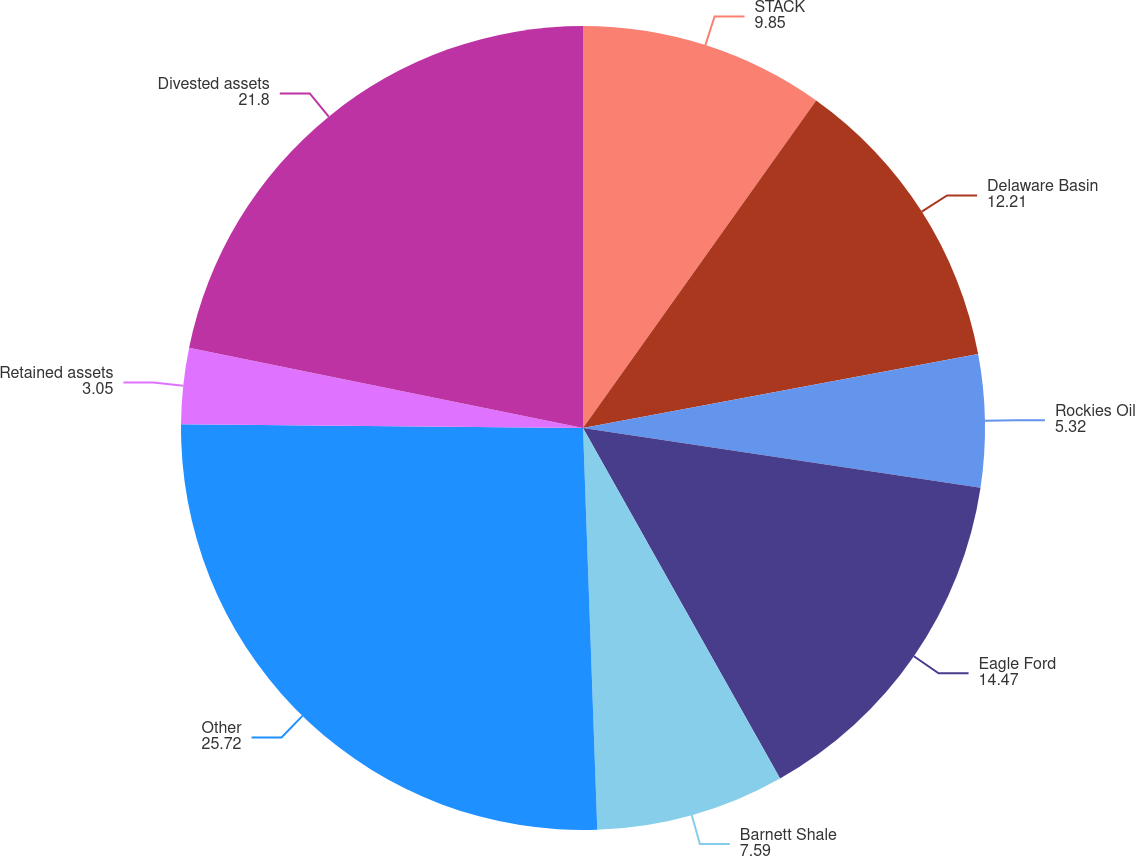<chart> <loc_0><loc_0><loc_500><loc_500><pie_chart><fcel>STACK<fcel>Delaware Basin<fcel>Rockies Oil<fcel>Eagle Ford<fcel>Barnett Shale<fcel>Other<fcel>Retained assets<fcel>Divested assets<nl><fcel>9.85%<fcel>12.21%<fcel>5.32%<fcel>14.47%<fcel>7.59%<fcel>25.72%<fcel>3.05%<fcel>21.8%<nl></chart> 